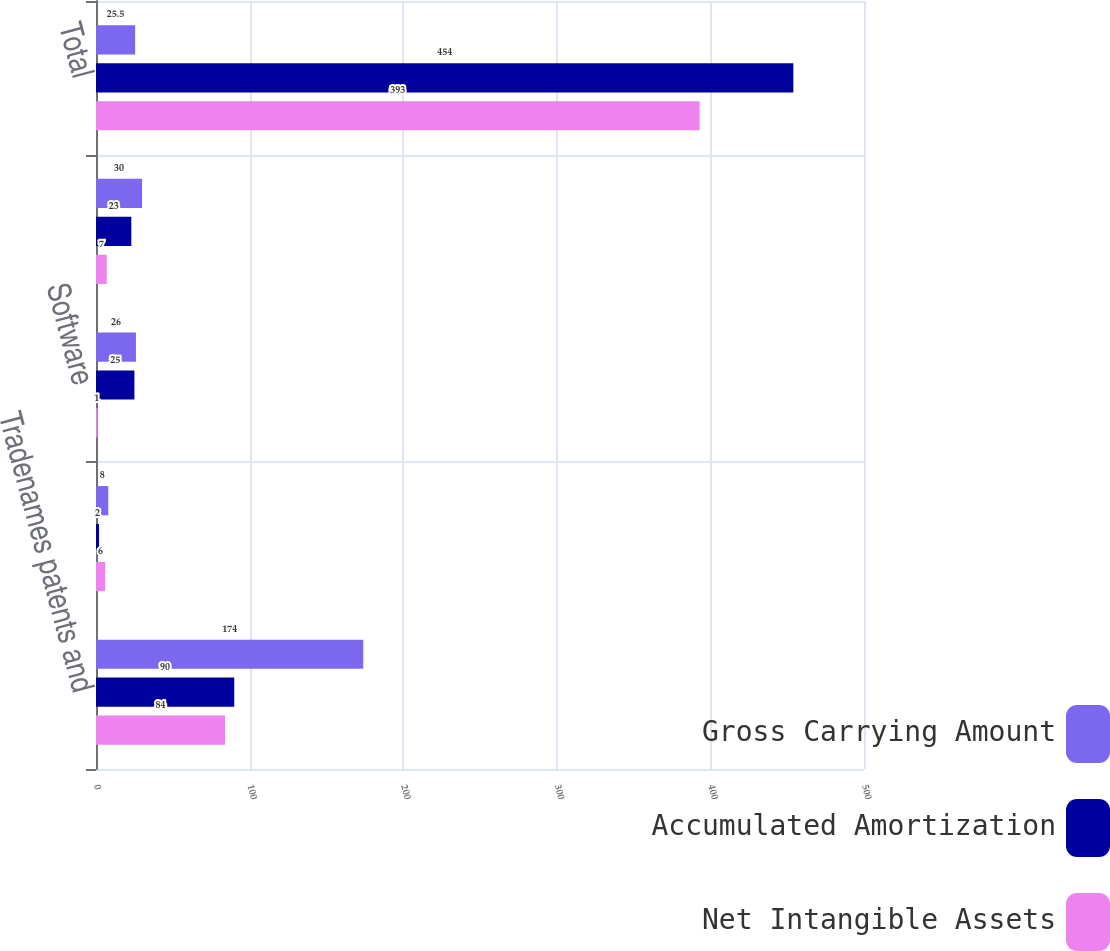Convert chart. <chart><loc_0><loc_0><loc_500><loc_500><stacked_bar_chart><ecel><fcel>Tradenames patents and<fcel>Land and water rights<fcel>Software<fcel>Other<fcel>Total<nl><fcel>Gross Carrying Amount<fcel>174<fcel>8<fcel>26<fcel>30<fcel>25.5<nl><fcel>Accumulated Amortization<fcel>90<fcel>2<fcel>25<fcel>23<fcel>454<nl><fcel>Net Intangible Assets<fcel>84<fcel>6<fcel>1<fcel>7<fcel>393<nl></chart> 